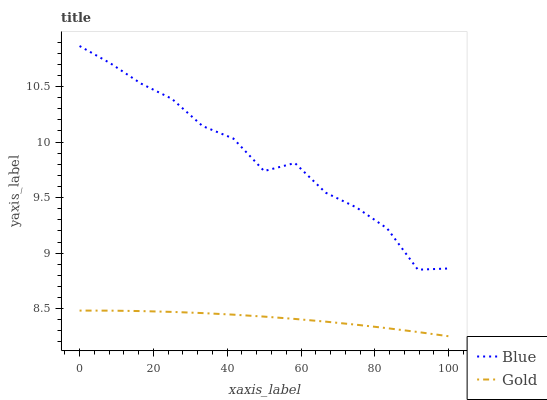Does Gold have the minimum area under the curve?
Answer yes or no. Yes. Does Blue have the maximum area under the curve?
Answer yes or no. Yes. Does Gold have the maximum area under the curve?
Answer yes or no. No. Is Gold the smoothest?
Answer yes or no. Yes. Is Blue the roughest?
Answer yes or no. Yes. Is Gold the roughest?
Answer yes or no. No. Does Gold have the lowest value?
Answer yes or no. Yes. Does Blue have the highest value?
Answer yes or no. Yes. Does Gold have the highest value?
Answer yes or no. No. Is Gold less than Blue?
Answer yes or no. Yes. Is Blue greater than Gold?
Answer yes or no. Yes. Does Gold intersect Blue?
Answer yes or no. No. 